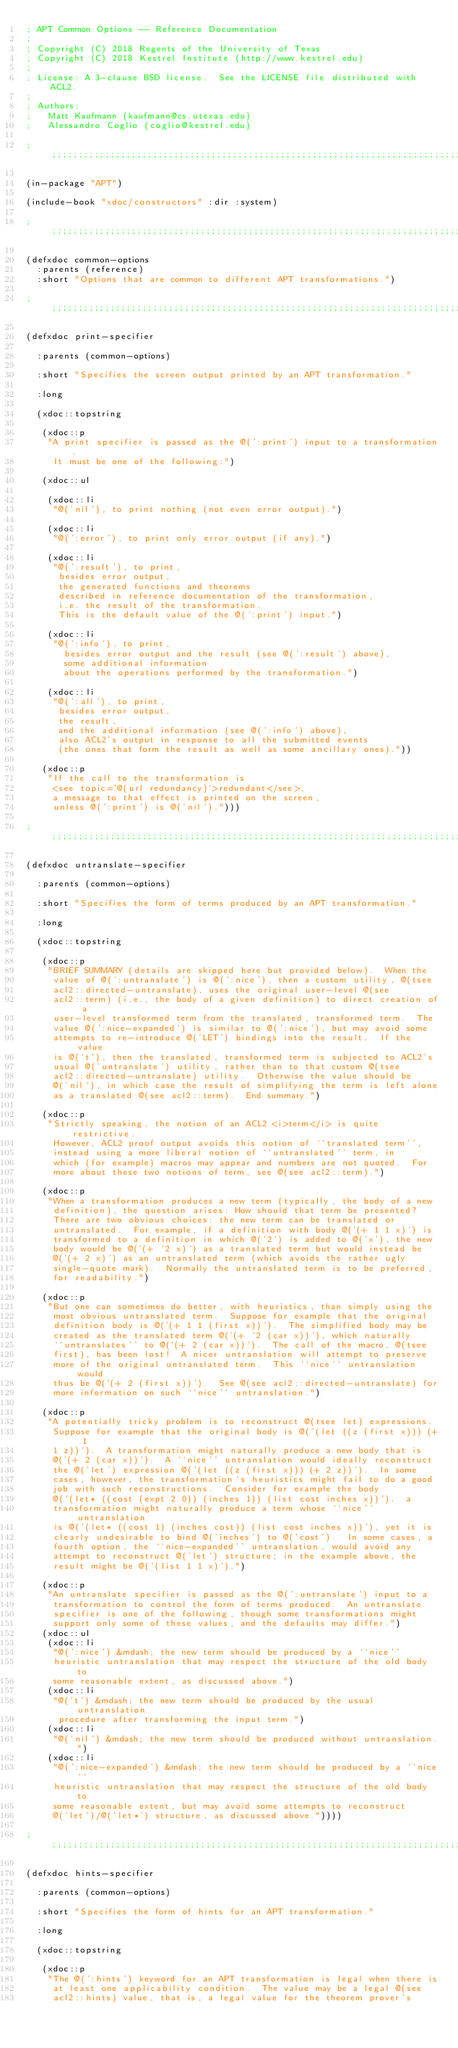<code> <loc_0><loc_0><loc_500><loc_500><_Lisp_>; APT Common Options -- Reference Documentation
;
; Copyright (C) 2018 Regents of the University of Texas
; Copyright (C) 2018 Kestrel Institute (http://www.kestrel.edu)
;
; License: A 3-clause BSD license.  See the LICENSE file distributed with ACL2.
;
; Authors:
;   Matt Kaufmann (kaufmann@cs.utexas.edu)
;   Alessandro Coglio (coglio@kestrel.edu)

;;;;;;;;;;;;;;;;;;;;;;;;;;;;;;;;;;;;;;;;;;;;;;;;;;;;;;;;;;;;;;;;;;;;;;;;;;;;;;;;

(in-package "APT")

(include-book "xdoc/constructors" :dir :system)

;;;;;;;;;;;;;;;;;;;;;;;;;;;;;;;;;;;;;;;;;;;;;;;;;;;;;;;;;;;;;;;;;;;;;;;;;;;;;;;;

(defxdoc common-options
  :parents (reference)
  :short "Options that are common to different APT transformations.")

;;;;;;;;;;;;;;;;;;;;;;;;;;;;;;;;;;;;;;;;;;;;;;;;;;;;;;;;;;;;;;;;;;;;;;;;;;;;;;;;

(defxdoc print-specifier

  :parents (common-options)

  :short "Specifies the screen output printed by an APT transformation."

  :long

  (xdoc::topstring

   (xdoc::p
    "A print specifier is passed as the @(':print') input to a transformation.
     It must be one of the following:")

   (xdoc::ul

    (xdoc::li
     "@('nil'), to print nothing (not even error output).")

    (xdoc::li
     "@(':error'), to print only error output (if any).")

    (xdoc::li
     "@(':result'), to print,
      besides error output,
      the generated functions and theorems
      described in reference documentation of the transformation,
      i.e. the result of the transformation.
      This is the default value of the @(':print') input.")

    (xdoc::li
     "@(':info'), to print,
       besides error output and the result (see @(':result') above),
       some additional information
       about the operations performed by the transformation.")

    (xdoc::li
     "@(':all'), to print,
      besides error output,
      the result,
      and the additional information (see @(':info') above),
      also ACL2's output in response to all the submitted events
      (the ones that form the result as well as some ancillary ones)."))

   (xdoc::p
    "If the call to the transformation is
     <see topic='@(url redundancy)'>redundant</see>,
     a message to that effect is printed on the screen,
     unless @(':print') is @('nil').")))

;;;;;;;;;;;;;;;;;;;;;;;;;;;;;;;;;;;;;;;;;;;;;;;;;;;;;;;;;;;;;;;;;;;;;;;;;;;;;;;;

(defxdoc untranslate-specifier

  :parents (common-options)

  :short "Specifies the form of terms produced by an APT transformation."

  :long

  (xdoc::topstring

   (xdoc::p
    "BRIEF SUMMARY (details are skipped here but provided below).  When the
     value of @(':untranslate') is @(':nice'), then a custom utility, @(tsee
     acl2::directed-untranslate), uses the original user-level @(see
     acl2::term) (i.e., the body of a given definition) to direct creation of a
     user-level transformed term from the translated, transformed term.  The
     value @(':nice-expanded') is similar to @(':nice'), but may avoid some
     attempts to re-introduce @('LET') bindings into the result.  If the value
     is @('t'), then the translated, transformed term is subjected to ACL2's
     usual @('untranslate') utility, rather than to that custom @(tsee
     acl2::directed-untranslate) utility.  Otherwise the value should be
     @('nil'), in which case the result of simplifying the term is left alone
     as a translated @(see acl2::term).  End summary.")

   (xdoc::p
    "Strictly speaking, the notion of an ACL2 <i>term</i> is quite restrictive.
     However, ACL2 proof output avoids this notion of ``translated term'',
     instead using a more liberal notion of ``untranslated'' term, in
     which (for example) macros may appear and numbers are not quoted.  For
     more about these two notions of term, see @(see acl2::term).")

   (xdoc::p
    "When a transformation produces a new term (typically, the body of a new
     definition), the question arises: How should that term be presented?
     There are two obvious choices: the new term can be translated or
     untranslated.  For example, if a definition with body @('(+ 1 1 x)') is
     transformed to a definition in which @('2') is added to @('x'), the new
     body would be @('(+ '2 x)') as a translated term but would instead be
     @('(+ 2 x)') as an untranslated term (which avoids the rather ugly
     single-quote mark).  Normally the untranslated term is to be preferred,
     for readability.")

   (xdoc::p
    "But one can sometimes do better, with heuristics, than simply using the
     most obvious untranslated term.  Suppose for example that the original
     definition body is @('(+ 1 1 (first x))').  The simplified body may be
     created as the translated term @('(+ '2 (car x))'), which naturally
     ``untranslates'' to @('(+ 2 (car x))').  The call of the macro, @(tsee
     first), has been lost!  A nicer untranslation will attempt to preserve
     more of the original untranslated term.  This ``nice'' untranslation would
     thus be @('(+ 2 (first x))').  See @(see acl2::directed-untranslate) for
     more information on such ``nice'' untranslation.")

   (xdoc::p
    "A potentially tricky problem is to reconstruct @(tsee let) expressions.
     Suppose for example that the original body is @('(let ((z (first x))) (+ 1
     1 z))').  A transformation might naturally produce a new body that is
     @('(+ 2 (car x))').  A ``nice'' untranslation would ideally reconstruct
     the @('let') expression @('(let ((z (first x))) (+ 2 z))').  In some
     cases, however, the transformation's heuristics might fail to do a good
     job with such reconstructions.  Consider for example the body
     @('(let* ((cost (expt 2 0)) (inches 1)) (list cost inches x))').  a
     transformation might naturally produce a term whose ``nice'' untranslation
     is @('(let* ((cost 1) (inches cost)) (list cost inches x))'), yet it is
     clearly undesirable to bind @('inches') to @('cost').  In some cases, a
     fourth option, the ``nice-expanded'' untranslation, would avoid any
     attempt to reconstruct @('let') structure; in the example above, the
     result might be @('(list 1 1 x)').")

   (xdoc::p
    "An untranslate specifier is passed as the @(':untranslate') input to a
     transformation to control the form of terms produced.  An untranslate
     specifier is one of the following, though some transformations might
     support only some of these values, and the defaults may differ.")
   (xdoc::ul
    (xdoc::li
     "@(':nice') &mdash; the new term should be produced by a ``nice''
     heuristic untranslation that may respect the structure of the old body to
     some reasonable extent, as discussed above.")
    (xdoc::li
     "@('t') &mdash; the new term should be produced by the usual untranslation
      procedure after transforming the input term.")
    (xdoc::li
     "@('nil') &mdash; the new term should be produced without untranslation.")
    (xdoc::li
     "@(':nice-expanded') &mdash; the new term should be produced by a ``nice''
     heuristic untranslation that may respect the structure of the old body to
     some reasonable extent, but may avoid some attempts to reconstruct
     @('let')/@('let*') structure, as discussed above."))))

;;;;;;;;;;;;;;;;;;;;;;;;;;;;;;;;;;;;;;;;;;;;;;;;;;;;;;;;;;;;;;;;;;;;;;;;;;;;;;;;

(defxdoc hints-specifier

  :parents (common-options)

  :short "Specifies the form of hints for an APT transformation."

  :long

  (xdoc::topstring

   (xdoc::p
    "The @(':hints') keyword for an APT transformation is legal when there is
     at least one applicability condition.  The value may be a legal @(see
     acl2::hints) value, that is, a legal value for the theorem prover's</code> 